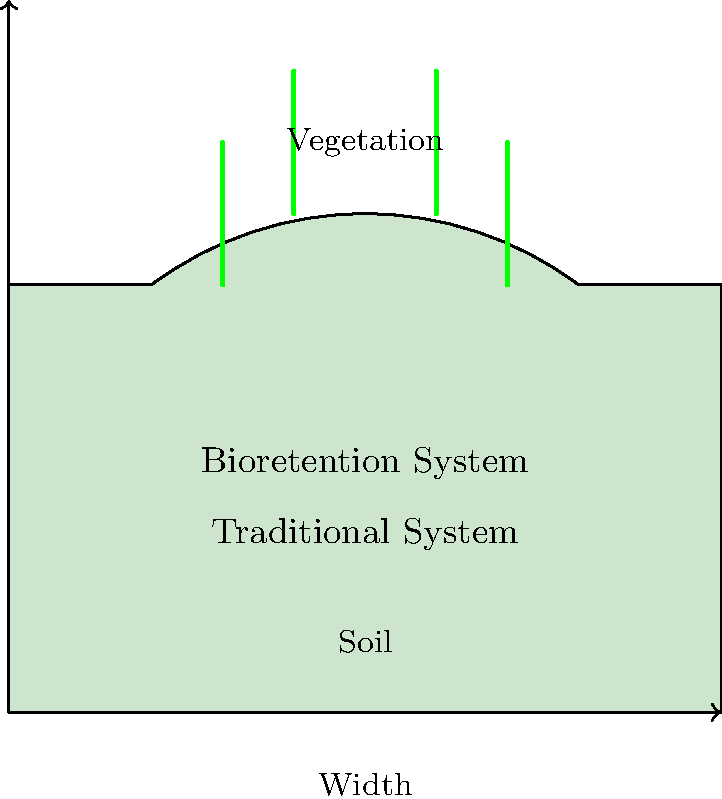Based on the cross-sectional diagrams of two stormwater management systems, which system is likely to be more effective in reducing peak runoff and improving water quality, and why might this present challenges for strict adherence to current legal regulations? To answer this question, let's analyze the two systems presented in the diagram:

1. Traditional System:
   - Simple rectangular cross-section
   - No vegetation or additional features
   - Primarily designed for rapid water conveyance

2. Bioretention System:
   - Curved cross-section with vegetation
   - Deeper and more complex structure
   - Includes soil and plant elements

Step-by-step analysis:

1. Runoff Reduction:
   - The bioretention system has a larger capacity due to its deeper profile.
   - The curved shape allows for temporary water storage, slowing down the flow.
   - Vegetation in the bioretention system intercepts and absorbs some of the water.

2. Water Quality Improvement:
   - The bioretention system's soil and vegetation act as natural filters.
   - Plants uptake nutrients and some pollutants.
   - Soil layers provide additional filtration and biological treatment.

3. Effectiveness:
   - The bioretention system is more effective in reducing peak runoff due to its storage capacity and flow reduction features.
   - It also provides superior water quality improvement through natural filtration processes.

4. Challenges for Current Regulations:
   - Existing regulations may be based on traditional systems and may not account for the benefits of bioretention.
   - The bioretention system might not comply with standardized dimensions or materials specified in current codes.
   - Performance metrics for the bioretention system may differ from those used for traditional systems, making direct comparisons difficult.
   - Implementation of bioretention systems might require changes to zoning laws, building codes, or drainage regulations.

5. Conflict with Strict Enforcement:
   - Strictly enforcing current regulations might prevent the adoption of more effective bioretention systems.
   - The bioretention system's non-standard design could be seen as non-compliant under rigid interpretation of existing laws.

In conclusion, while the bioretention system is likely more effective for stormwater management, its adoption may be hindered by strict adherence to regulations designed for traditional systems. This presents a challenge for policymakers who must balance the benefits of newer, more effective systems with the need for consistent and enforceable standards.
Answer: Bioretention system; challenges existing regulations designed for traditional systems. 